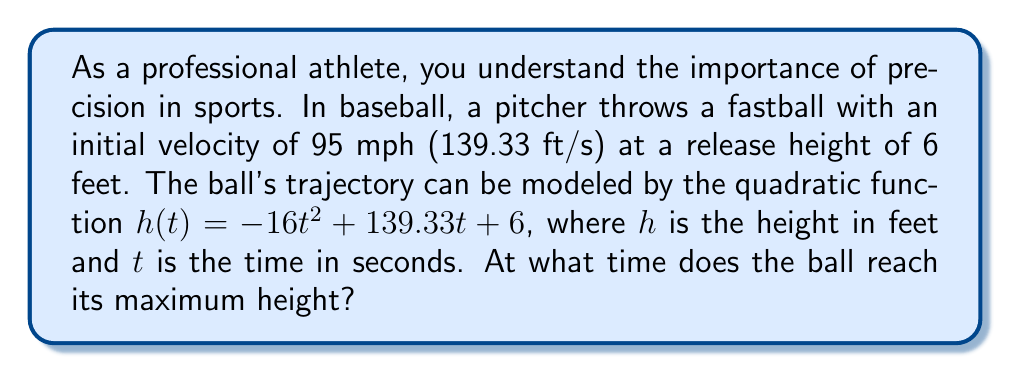Show me your answer to this math problem. To find the time when the ball reaches its maximum height, we need to follow these steps:

1) The quadratic function given is:
   $h(t) = -16t^2 + 139.33t + 6$

2) In a quadratic function of the form $f(t) = at^2 + bt + c$, the vertex occurs at $t = -\frac{b}{2a}$. This t-value represents the time at which the maximum height is reached.

3) In our function:
   $a = -16$
   $b = 139.33$

4) Applying the formula:
   $t = -\frac{b}{2a} = -\frac{139.33}{2(-16)} = \frac{139.33}{32} \approx 4.35$

5) Therefore, the ball reaches its maximum height at approximately 4.35 seconds after it's thrown.

To verify, we can calculate the height at this time:
$h(4.35) = -16(4.35)^2 + 139.33(4.35) + 6 \approx 309.19$ feet

This is indeed the maximum height of the trajectory.
Answer: 4.35 seconds 